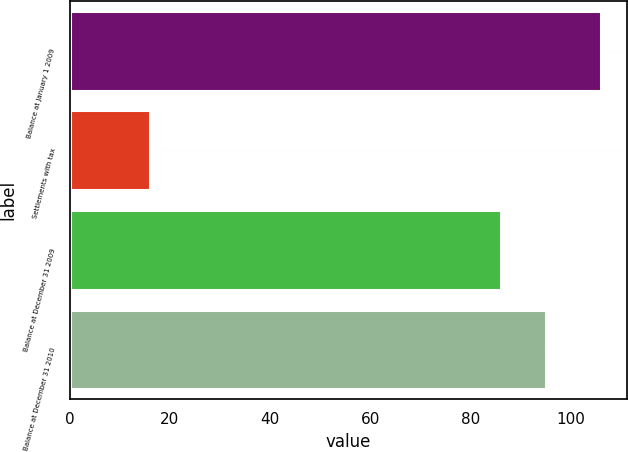Convert chart. <chart><loc_0><loc_0><loc_500><loc_500><bar_chart><fcel>Balance at January 1 2009<fcel>Settlements with tax<fcel>Balance at December 31 2009<fcel>Balance at December 31 2010<nl><fcel>106<fcel>16<fcel>86<fcel>95<nl></chart> 